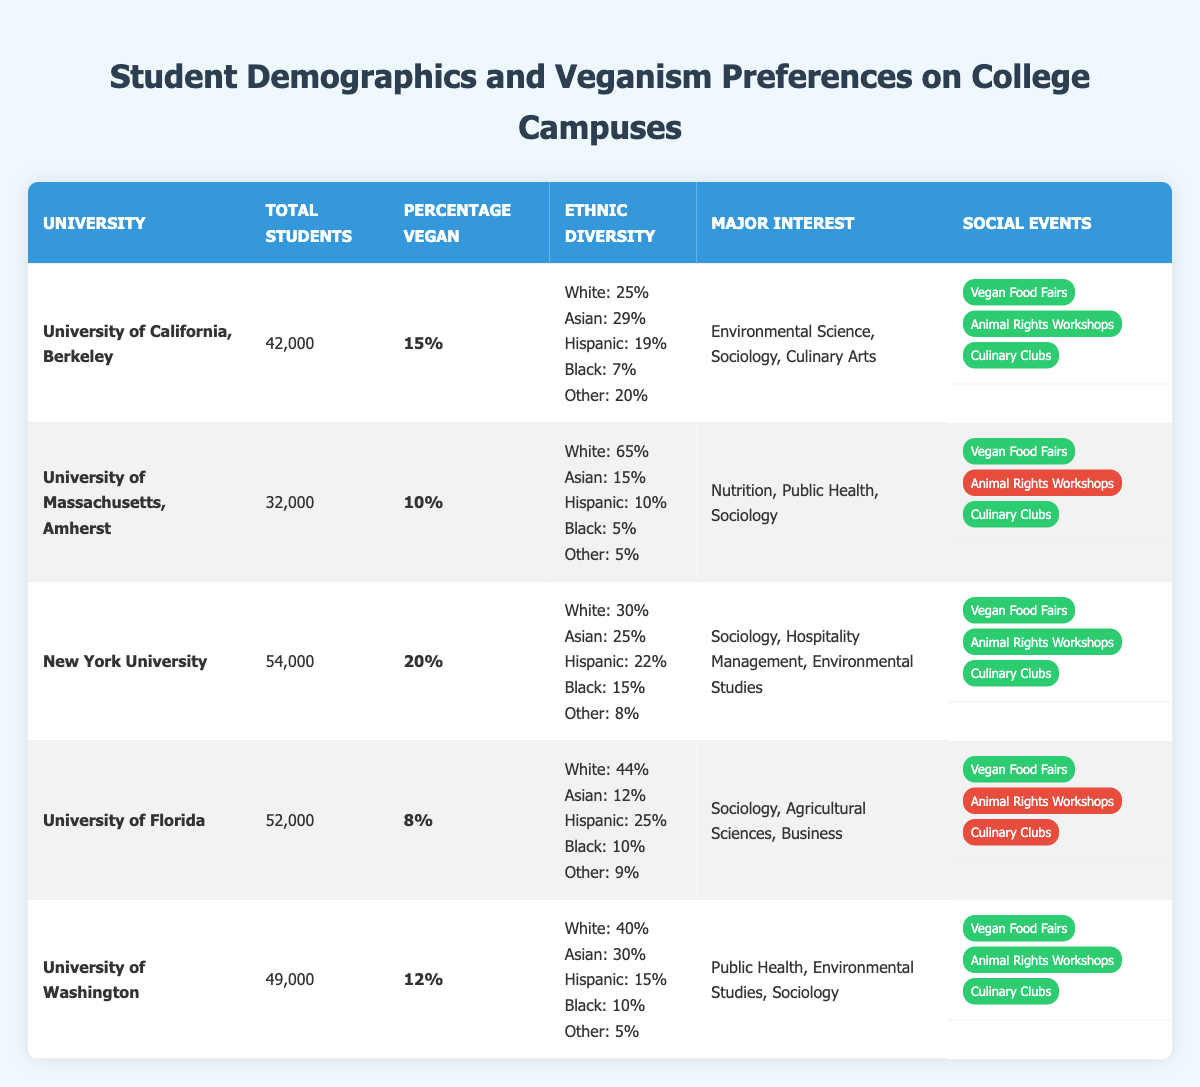What is the percentage of vegan students at New York University? The table indicates the percentage of vegan students at New York University as 20%.
Answer: 20% How many total students are enrolled at the University of Florida? The table shows that the total number of students at the University of Florida is 52,000.
Answer: 52,000 Which university has the highest percentage of vegan students? By comparing the percentages in the table, New York University has the highest percentage of vegan students at 20%.
Answer: New York University Is there an animal rights workshop at the University of Massachusetts, Amherst? The table notes that the University of Massachusetts, Amherst does not have animal rights workshops available, as indicated by the false status.
Answer: No How many universities have vegan food fairs? By counting the entries in the social events section of the table, it can be noted that all universities except the University of Florida have vegan food fairs. Therefore, 4 universities have vegan food fairs.
Answer: 4 Calculate the average percentage of vegan students across all universities listed. The percentage of vegan students is 15%, 10%, 20%, 8%, and 12%. Adding these gives 65%. Dividing by the number of universities, 65/5 equals 13%.
Answer: 13% Which university has the most diverse ethnic demographics? The University of Massachusetts, Amherst, has the highest percentage of White students (65%), while all others have lower percentages, indicating less ethnic diversity. The university with the least percentage of any ethnic group would be University of Massachusetts, Amherst.
Answer: University of Massachusetts, Amherst What is the total number of students at the University of California, Berkeley compared to the University of Washington? The table shows that the University of California, Berkeley has 42,000 students, while the University of Washington has 49,000 students. Thus, University of Washington has more students than UC Berkeley by 7,000.
Answer: University of Washington Count the number of social events offered at the University of California, Berkeley. According to the table, the University of California, Berkeley offers three social events: Vegan Food Fairs, Animal Rights Workshops, and Culinary Clubs.
Answer: 3 How does the ethnic diversity of the University of Florida compare with New York University? The table shows that the University of Florida has 44% White, 12% Asian, 25% Hispanic, 10% Black, and 9% Other. In contrast, New York University has 30% White, 25% Asian, 22% Hispanic, 15% Black, and 8% Other. University of Florida has a higher percentage of Hispanic and White students while NYU has a higher percentage of Asian and Black students.
Answer: Varied percentages in different groups 